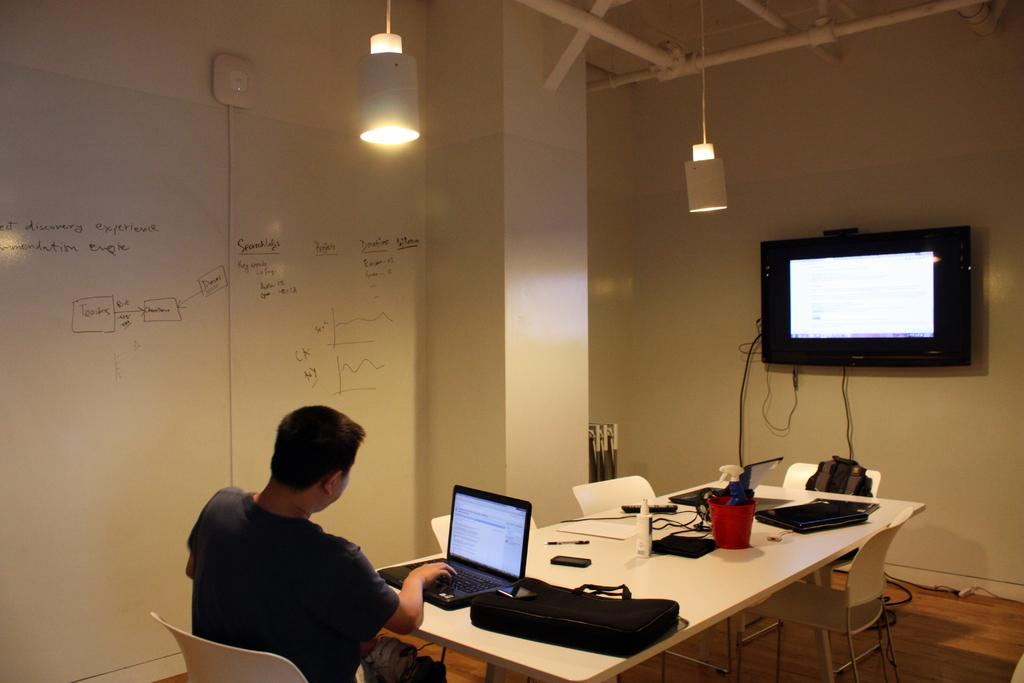What is the man in the image doing? The man is sitting and working on a laptop in the image. What is the man using to work on in the image? The man is using a laptop to work on in the image. What is the man sitting at in the image? The man is sitting at a table in the image. What can be seen on the table in the image? There are objects on the table in the image. What is visible in the background of the image? There is a wall and a screen visible in the background of the image. What type of glass is the man drinking from in the image? There is no glass visible in the image; the man is working on a laptop. What is the purpose of the son in the image? There is no mention of a son in the image; the main subject is a man working on a laptop. 